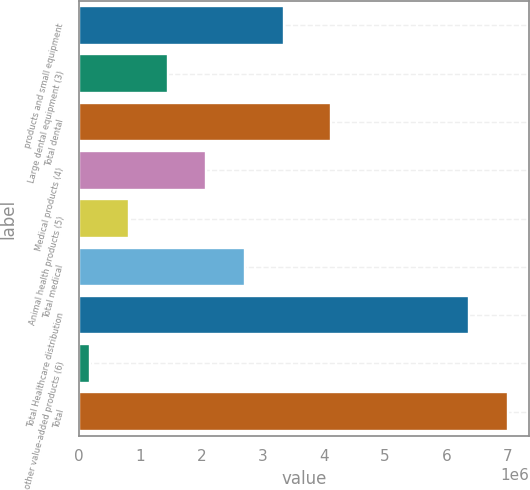Convert chart. <chart><loc_0><loc_0><loc_500><loc_500><bar_chart><fcel>products and small equipment<fcel>Large dental equipment (3)<fcel>Total dental<fcel>Medical products (4)<fcel>Animal health products (5)<fcel>Total medical<fcel>Total Healthcare distribution<fcel>other value-added products (6)<fcel>Total<nl><fcel>3.35577e+06<fcel>1.44623e+06<fcel>4.11321e+06<fcel>2.08275e+06<fcel>809721<fcel>2.71926e+06<fcel>6.36513e+06<fcel>173208<fcel>7.00164e+06<nl></chart> 